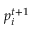Convert formula to latex. <formula><loc_0><loc_0><loc_500><loc_500>p _ { i } ^ { t + 1 }</formula> 